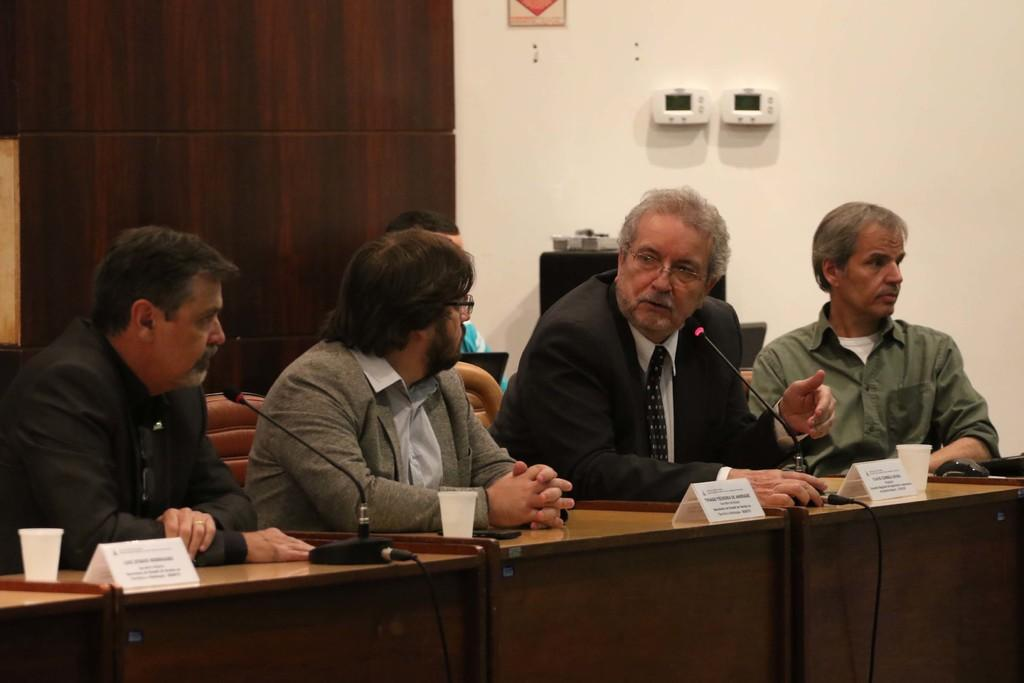What is located at the bottom of the image? There is a table at the bottom of the image. What objects are on the table? There are cups and microphones on the table. Who is present near the table? There are people sitting behind the table. What can be seen at the top of the image? There is a wall at the top of the image. Is there a baseball game happening in the image? No, there is no baseball game present in the image. Can you see a kitty playing with the microphones in the image? No, there is no kitty present in the image. 